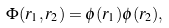<formula> <loc_0><loc_0><loc_500><loc_500>\Phi ( { r } _ { 1 } , { r } _ { 2 } ) = \phi ( r _ { 1 } ) \phi ( r _ { 2 } ) ,</formula> 